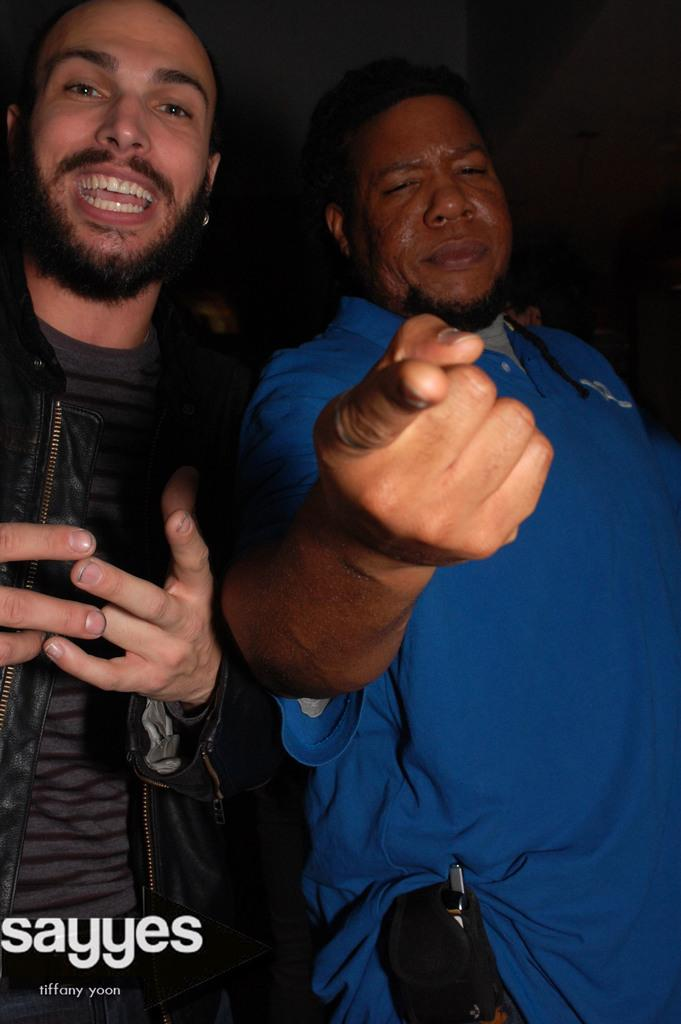Who is present in the image? There is a man in the image. What is the man doing in the image? The man is standing. What type of guitar is the man playing in the image? There is no guitar present in the image; the man is simply standing. How many ants can be seen crawling on the man's shoes in the image? There are no ants visible in the image. 